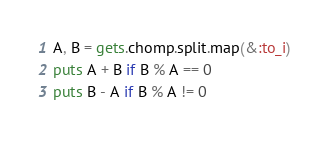Convert code to text. <code><loc_0><loc_0><loc_500><loc_500><_Ruby_>A, B = gets.chomp.split.map(&:to_i)
puts A + B if B % A == 0
puts B - A if B % A != 0</code> 